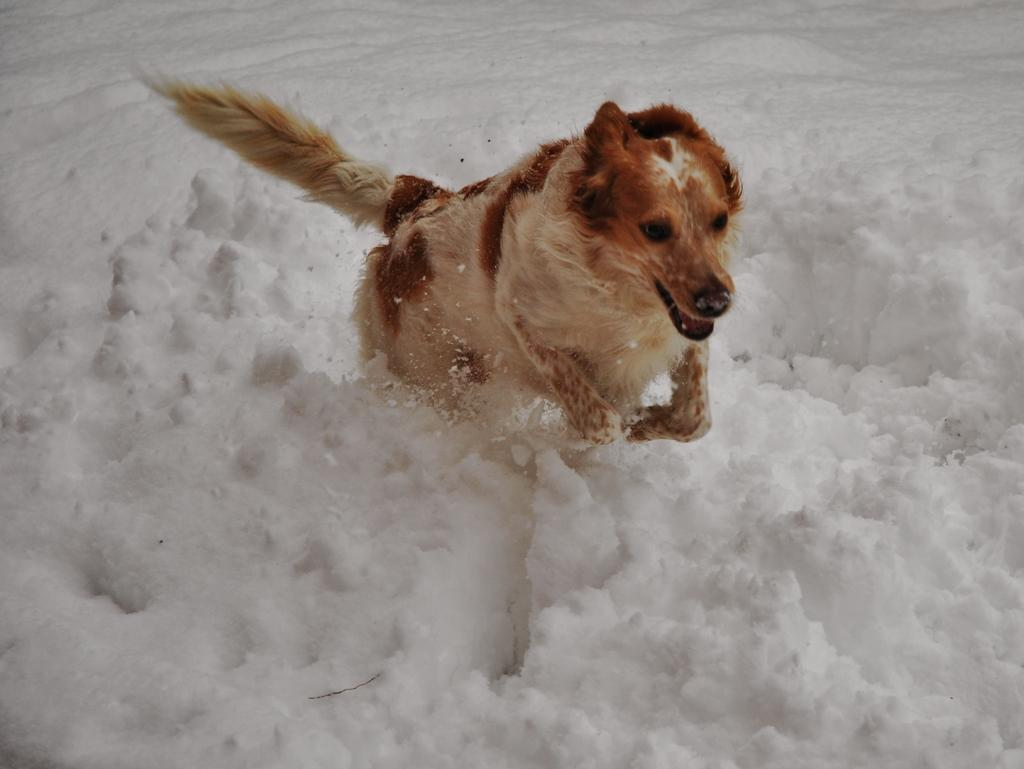What is the main subject in the center of the image? There is a dog in the center of the image. Can you describe the white-colored object in the image? Unfortunately, there is not enough information provided to describe the white-colored object in the image. What type of coal is being used to grade the dog's performance in the image? There is no coal or grading mentioned in the image, and the dog's performance is not being evaluated. 